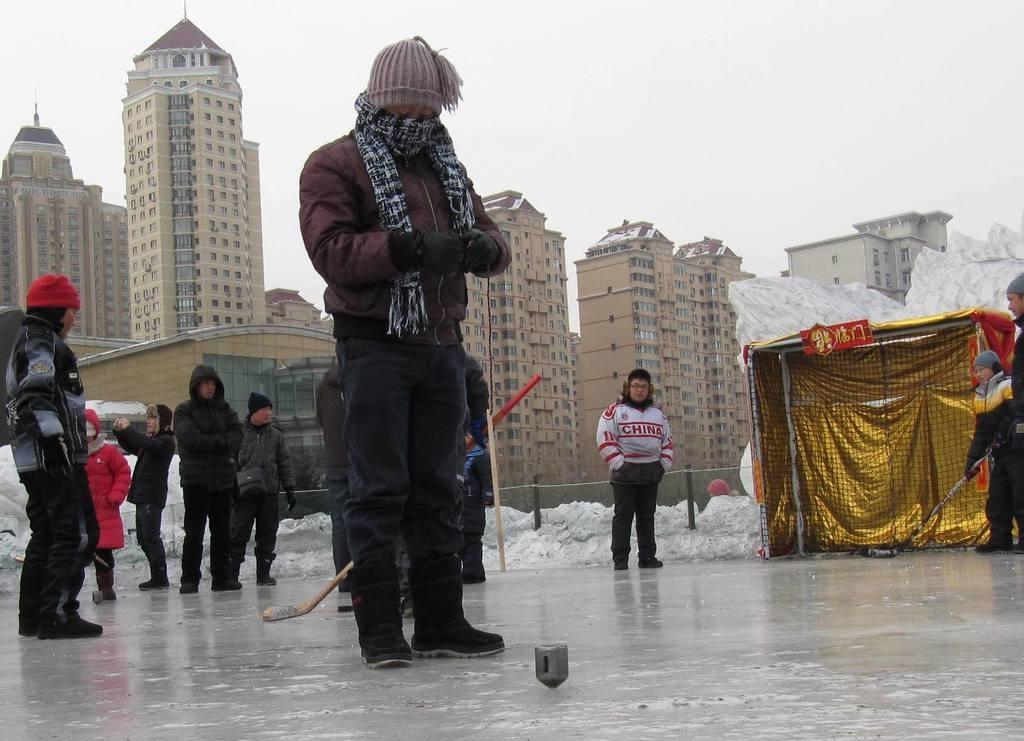How many people are in the image? There are people in the image, but the exact number is not specified. What can be seen in the image besides the people? There is a stick, objects on the surface, a board on a tent, poles, snow, buildings, and the sky visible in the background. What is the board on in the image? The board is on a tent in the image. What is the weather like in the image? The presence of snow suggests that it is cold and possibly snowy. What type of hall can be seen in the image? There is no hall present in the image. Are there any firemen visible in the image? There is no mention of firemen in the image. 